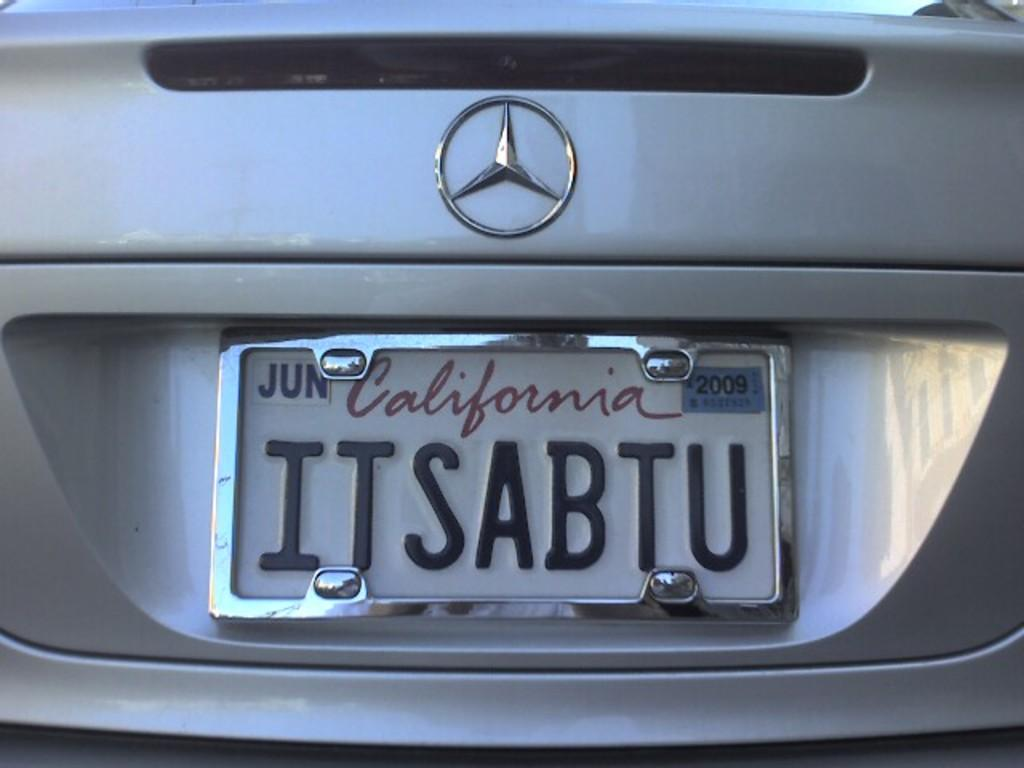<image>
Provide a brief description of the given image. A silver car with the license plate Itsabtu. 